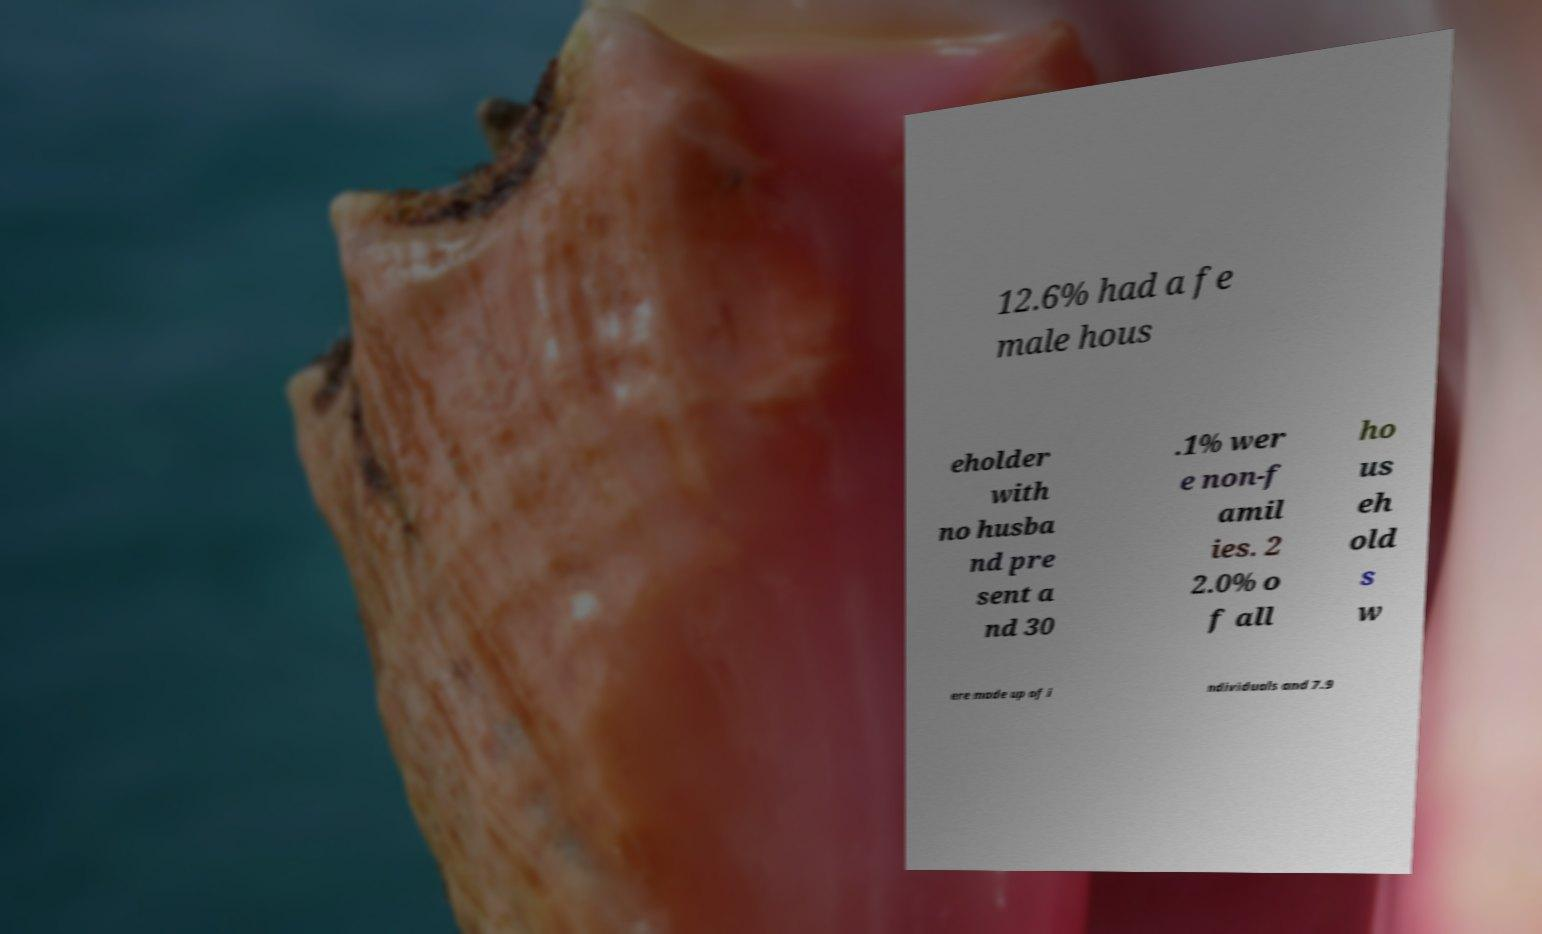For documentation purposes, I need the text within this image transcribed. Could you provide that? 12.6% had a fe male hous eholder with no husba nd pre sent a nd 30 .1% wer e non-f amil ies. 2 2.0% o f all ho us eh old s w ere made up of i ndividuals and 7.9 